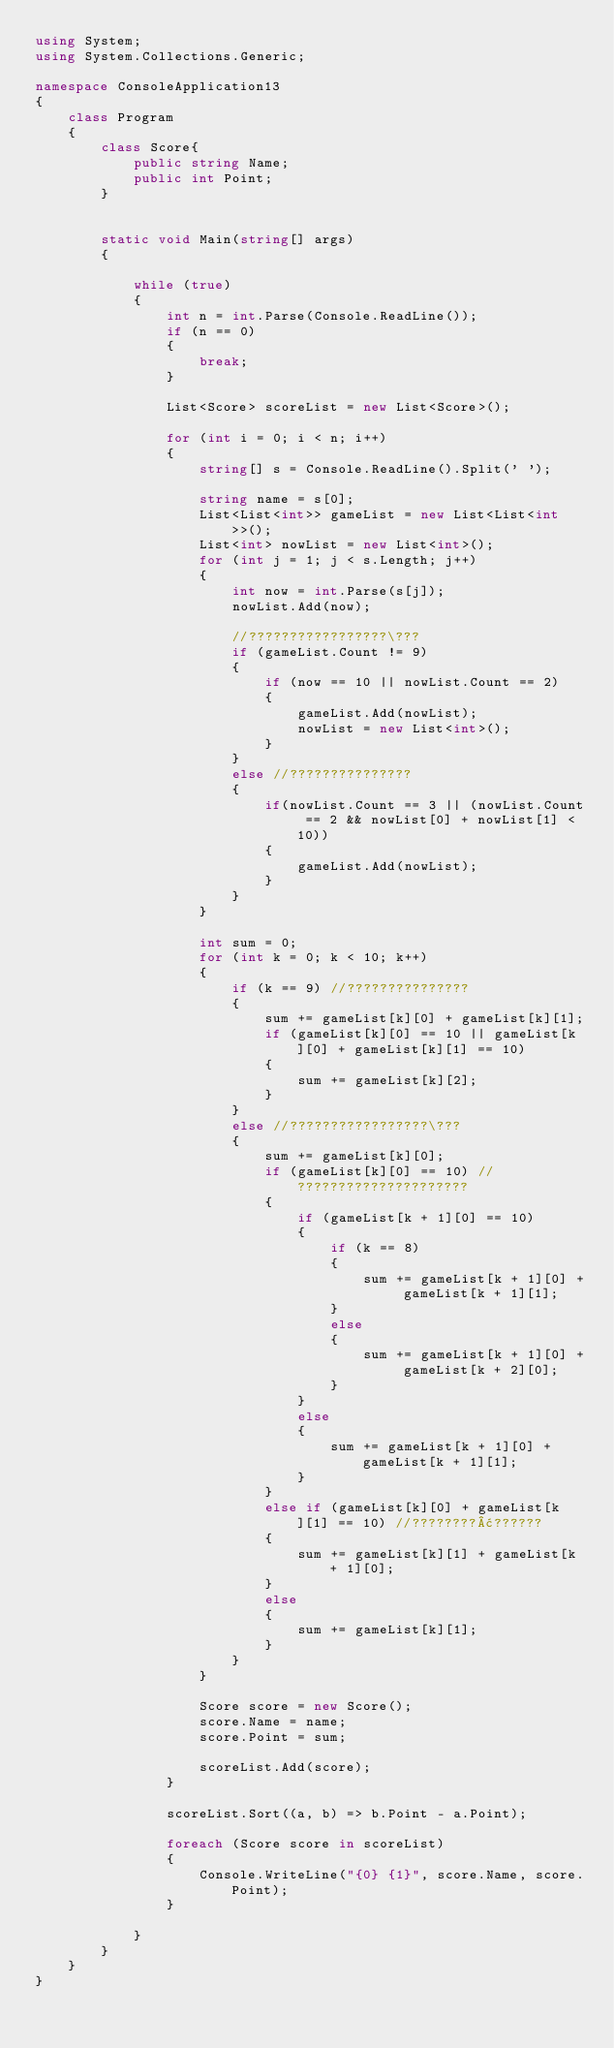Convert code to text. <code><loc_0><loc_0><loc_500><loc_500><_C#_>using System;
using System.Collections.Generic;

namespace ConsoleApplication13
{
    class Program
    {
        class Score{
            public string Name;
            public int Point;
        }


        static void Main(string[] args)
        {

            while (true)
            {
                int n = int.Parse(Console.ReadLine());
                if (n == 0)
                {
                    break;
                }

                List<Score> scoreList = new List<Score>();

                for (int i = 0; i < n; i++)
                {
                    string[] s = Console.ReadLine().Split(' ');

                    string name = s[0];
                    List<List<int>> gameList = new List<List<int>>();
                    List<int> nowList = new List<int>();
                    for (int j = 1; j < s.Length; j++)
                    {
                        int now = int.Parse(s[j]);
                        nowList.Add(now);

                        //?????????????????\???
                        if (gameList.Count != 9)
                        {
                            if (now == 10 || nowList.Count == 2)
                            {
                                gameList.Add(nowList);
                                nowList = new List<int>();
                            }
                        }
                        else //???????????????
                        {
                            if(nowList.Count == 3 || (nowList.Count == 2 && nowList[0] + nowList[1] < 10))
                            {
                                gameList.Add(nowList);
                            }
                        }
                    }

                    int sum = 0;
                    for (int k = 0; k < 10; k++)
                    {
                        if (k == 9) //???????????????
                        {
                            sum += gameList[k][0] + gameList[k][1];
                            if (gameList[k][0] == 10 || gameList[k][0] + gameList[k][1] == 10)
                            {
                                sum += gameList[k][2];
                            }
                        }
                        else //?????????????????\???
                        {
                            sum += gameList[k][0];
                            if (gameList[k][0] == 10) //?????????????????????
                            {
                                if (gameList[k + 1][0] == 10)
                                {
                                    if (k == 8)
                                    {
                                        sum += gameList[k + 1][0] + gameList[k + 1][1];
                                    }
                                    else
                                    {
                                        sum += gameList[k + 1][0] + gameList[k + 2][0];
                                    }
                                }
                                else
                                {
                                    sum += gameList[k + 1][0] + gameList[k + 1][1];
                                }
                            }
                            else if (gameList[k][0] + gameList[k][1] == 10) //????????¢??????
                            {
                                sum += gameList[k][1] + gameList[k + 1][0];
                            }
                            else
                            {
                                sum += gameList[k][1];
                            }
                        }
                    }

                    Score score = new Score();
                    score.Name = name;
                    score.Point = sum;

                    scoreList.Add(score);
                }

                scoreList.Sort((a, b) => b.Point - a.Point);

                foreach (Score score in scoreList)
                {
                    Console.WriteLine("{0} {1}", score.Name, score.Point);
                }

            }
        }
    }
}</code> 